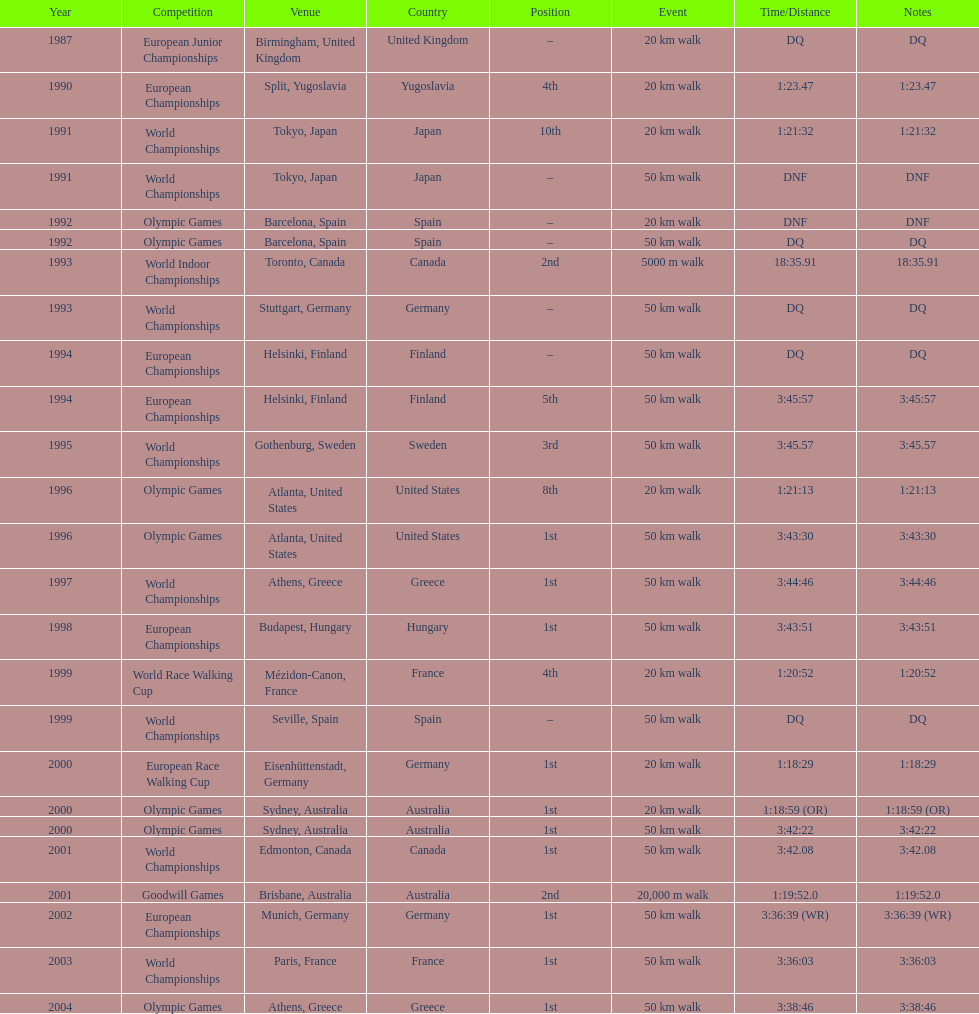How many times did korzeniowski finish above fourth place? 13. 